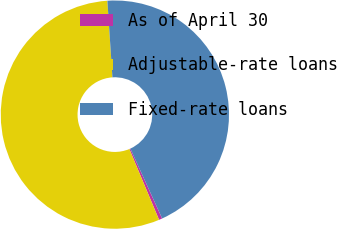Convert chart. <chart><loc_0><loc_0><loc_500><loc_500><pie_chart><fcel>As of April 30<fcel>Adjustable-rate loans<fcel>Fixed-rate loans<nl><fcel>0.47%<fcel>55.28%<fcel>44.25%<nl></chart> 